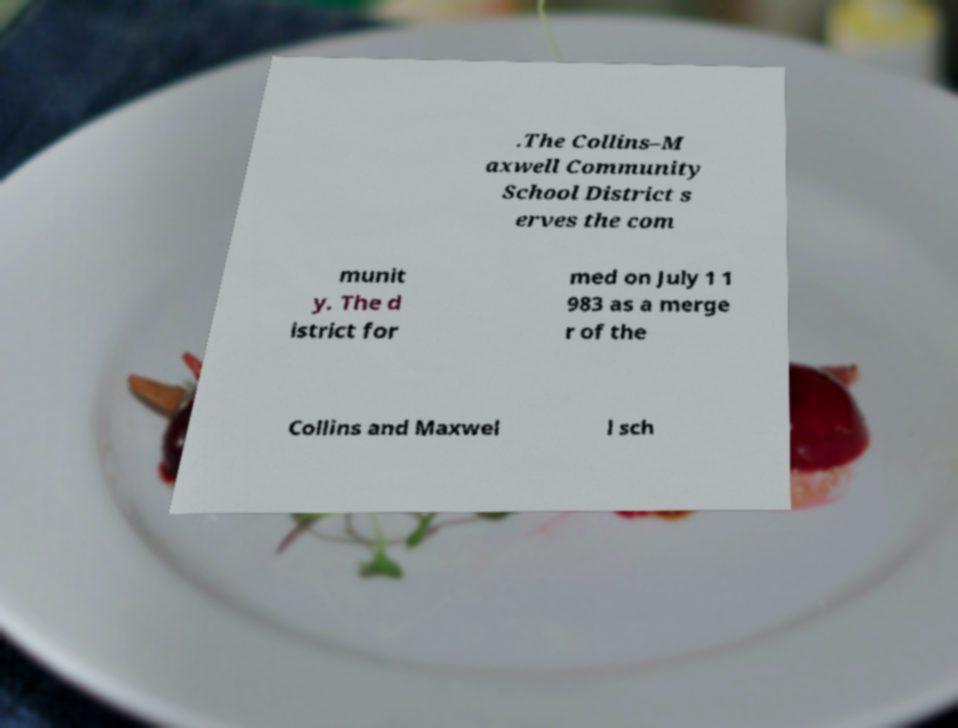For documentation purposes, I need the text within this image transcribed. Could you provide that? .The Collins–M axwell Community School District s erves the com munit y. The d istrict for med on July 1 1 983 as a merge r of the Collins and Maxwel l sch 